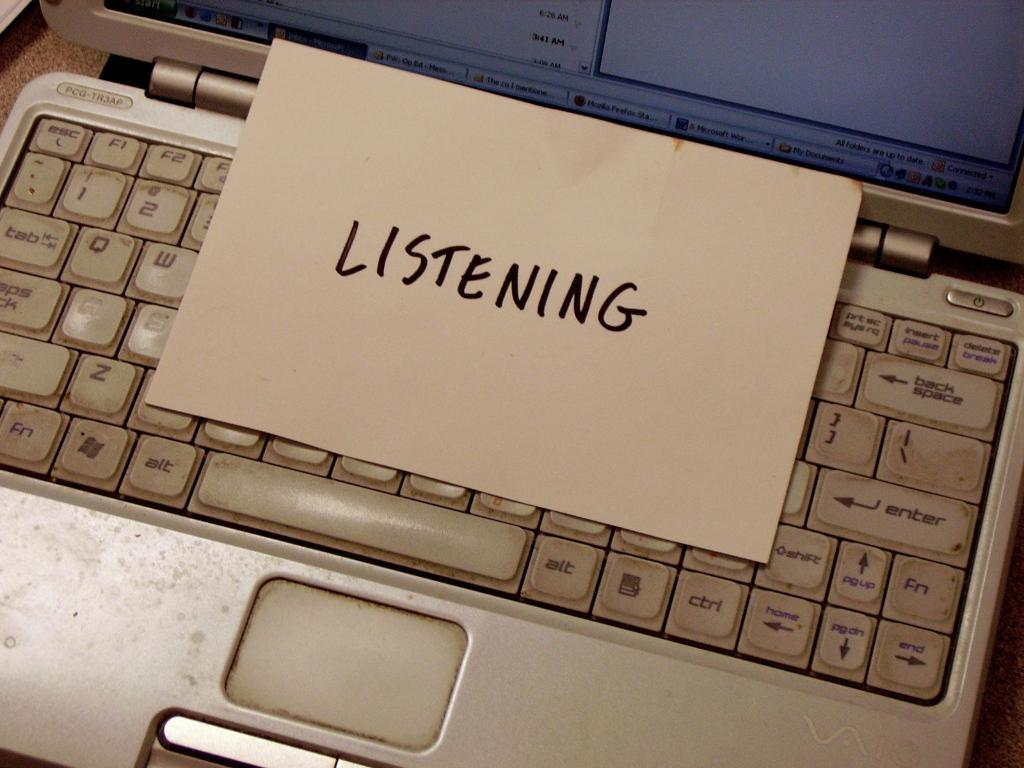<image>
Create a compact narrative representing the image presented. A note that reads Listening is left on a dirty keyboard. 